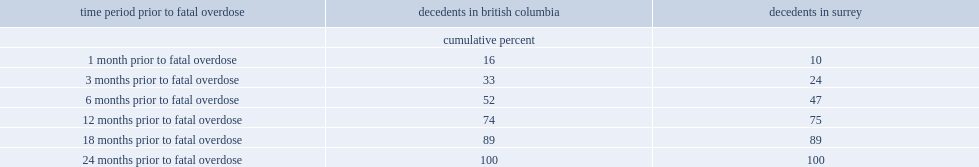Among all decedents in british columbia and surrey, what is the percentage of those who experienced their fatal overdose within one year after their contact with police? 75.0. 